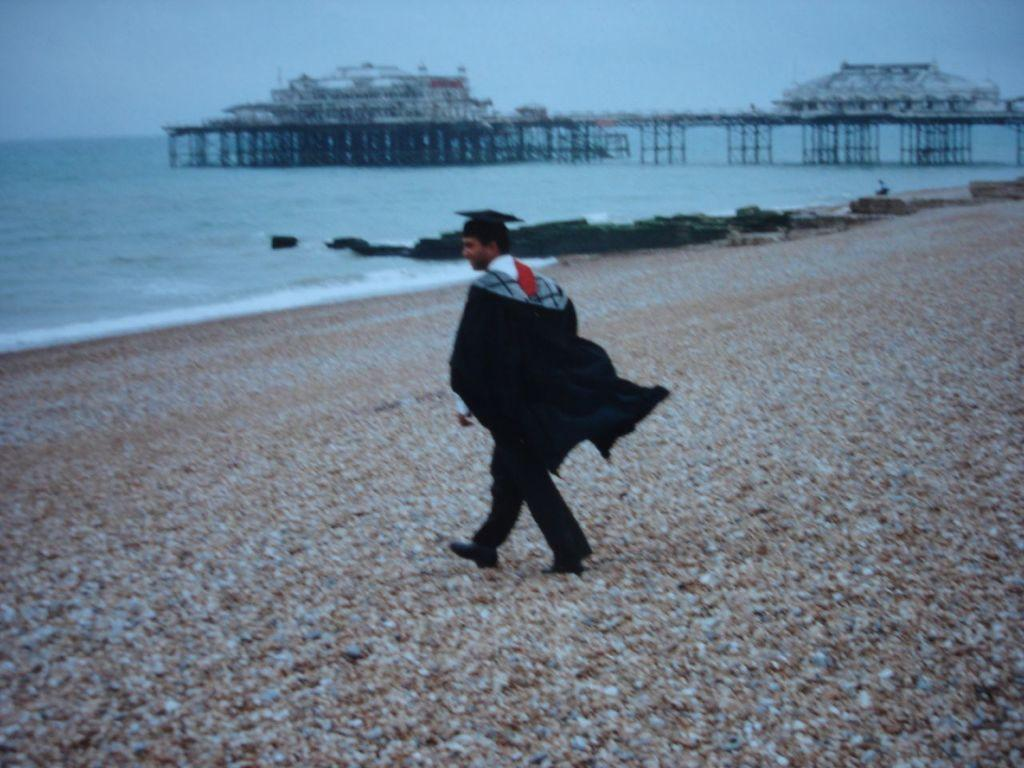What is the person in the image doing? The person is walking in the image. Where is the person located in the image? The person is near the seashore. What can be seen on the pier in the image? There are architects on the pier. What is visible in the background of the image? Water and the sky are visible in the background. What type of dinosaurs can be seen in the image? There are no dinosaurs present in the image; it features a person walking near the seashore. What is the heart rate of the person walking in the image? There is no way to determine the person's heart rate from the image. 